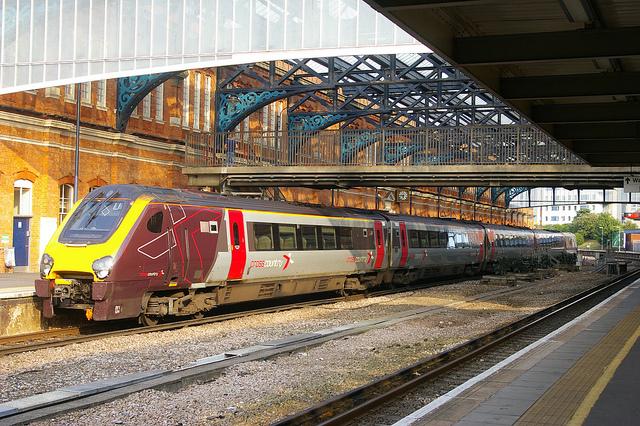Is it raining?
Keep it brief. No. Is there a train?
Answer briefly. Yes. Is the train stopping?
Keep it brief. Yes. 